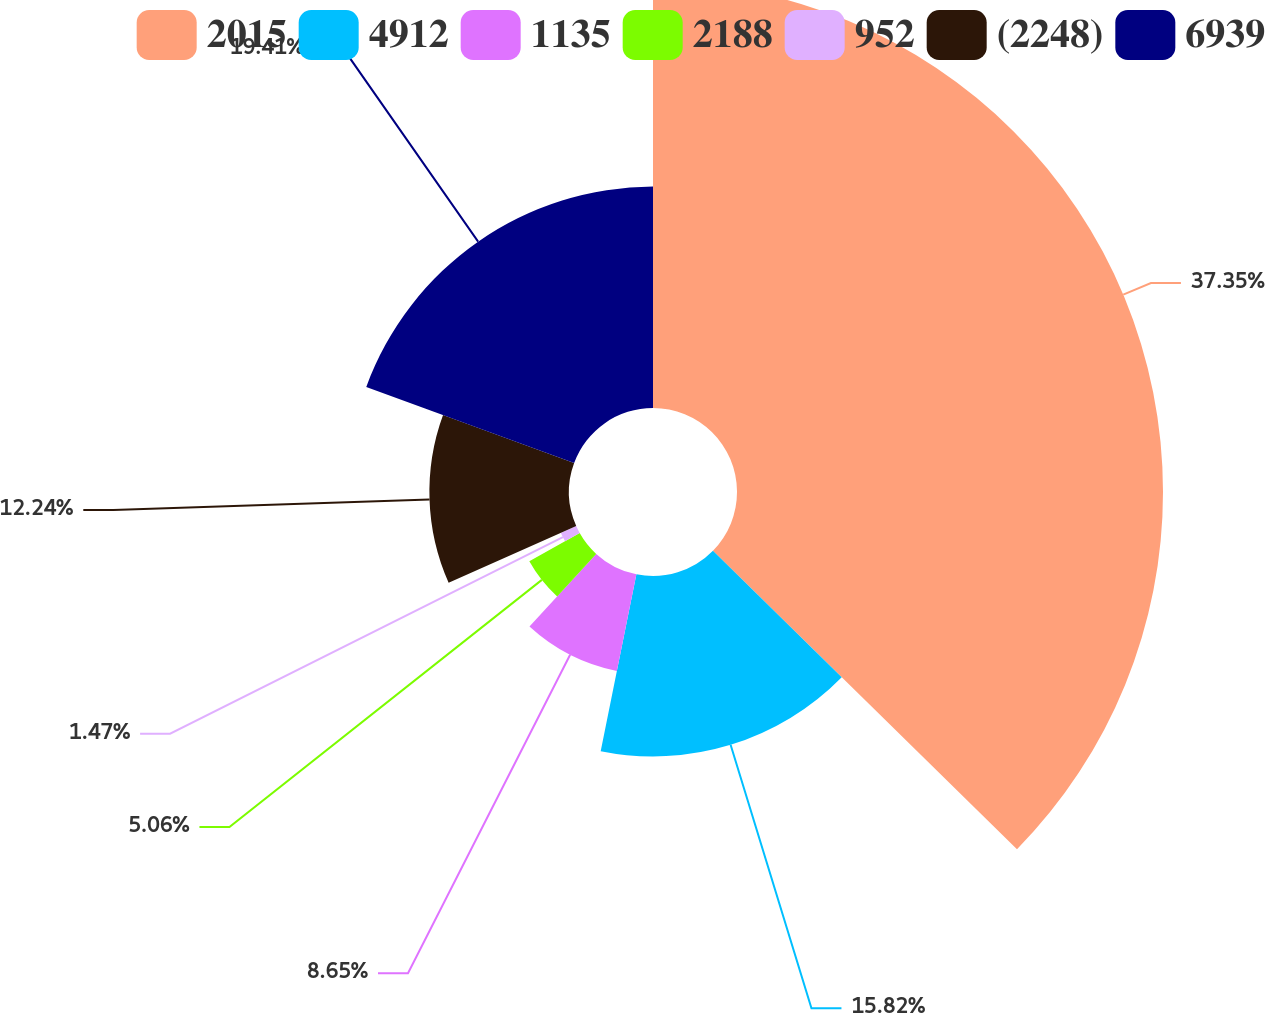Convert chart. <chart><loc_0><loc_0><loc_500><loc_500><pie_chart><fcel>2015<fcel>4912<fcel>1135<fcel>2188<fcel>952<fcel>(2248)<fcel>6939<nl><fcel>37.35%<fcel>15.82%<fcel>8.65%<fcel>5.06%<fcel>1.47%<fcel>12.24%<fcel>19.41%<nl></chart> 